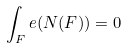<formula> <loc_0><loc_0><loc_500><loc_500>\int _ { F } e ( N ( F ) ) = 0</formula> 